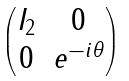<formula> <loc_0><loc_0><loc_500><loc_500>\begin{pmatrix} I _ { 2 } & 0 \\ 0 & e ^ { - i \theta } \end{pmatrix}</formula> 